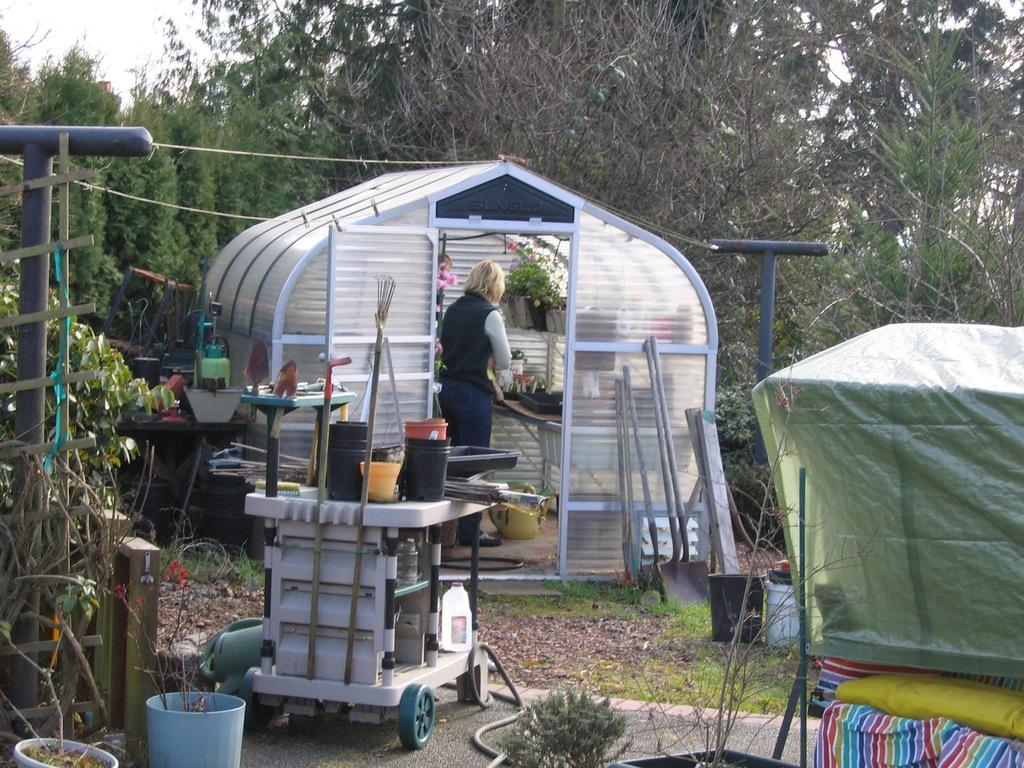What type of living organisms can be seen in the room? Plants are present in the room. Who is in the room? There is a woman in the room. What can be seen outside the room? Trees are visible outside the room. What materials are present in the image? Metal rods, a bucket, a cart, and a pipe are visible in the image. What year is depicted in the image? The image does not depict a specific year; it is a still image of a room with various objects and people. How many boys are present in the image? There is no boy present in the image; it features a woman and various objects. 